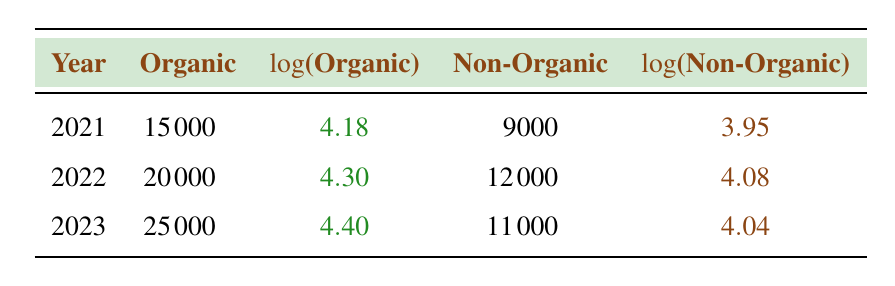What is the organic revenue in 2022? The table shows the organic revenue for the year 2022 as 20000.
Answer: 20000 What is the non-organic revenue for 2021? According to the table, the non-organic revenue for 2021 is listed as 9000.
Answer: 9000 Which year had the highest organic revenue? By looking at the organic revenue values, 2023 has the highest value at 25000, compared to 2021 at 15000 and 2022 at 20000.
Answer: 2023 What is the difference in organic revenue between 2022 and 2021? The organic revenue in 2022 is 20000, and in 2021, it is 15000. The difference is calculated by subtracting 15000 from 20000, which equals 5000.
Answer: 5000 Is the non-organic revenue higher in 2022 than in 2023? In 2022, the non-organic revenue is 12000, while in 2023, it is 11000. Since 12000 is greater than 11000, the statement is true.
Answer: Yes What is the average organic revenue over the three years? To find the average organic revenue, add all three organic revenues: 15000 + 20000 + 25000 = 60000. Then, divide by 3 because there are three years: 60000 / 3 = 20000.
Answer: 20000 Is it true that the logarithmic value of the organic revenue in 2023 is greater than that in 2021? Looking at the logarithmic values, in 2023 the value is 4.40 and in 2021 it is 4.18. Since 4.40 is greater than 4.18, the statement is true.
Answer: Yes What was the total revenue (organic + non-organic) in 2022? For 2022, the organic revenue is 20000 and the non-organic revenue is 12000. Adding them together gives: 20000 + 12000 = 32000.
Answer: 32000 Which year saw a decrease in non-organic revenue compared to the previous year? The non-organic revenue for 2022 is 12000, while in 2023 it decreased to 11000. This indicates a decrease in 2023 compared to 2022.
Answer: 2023 